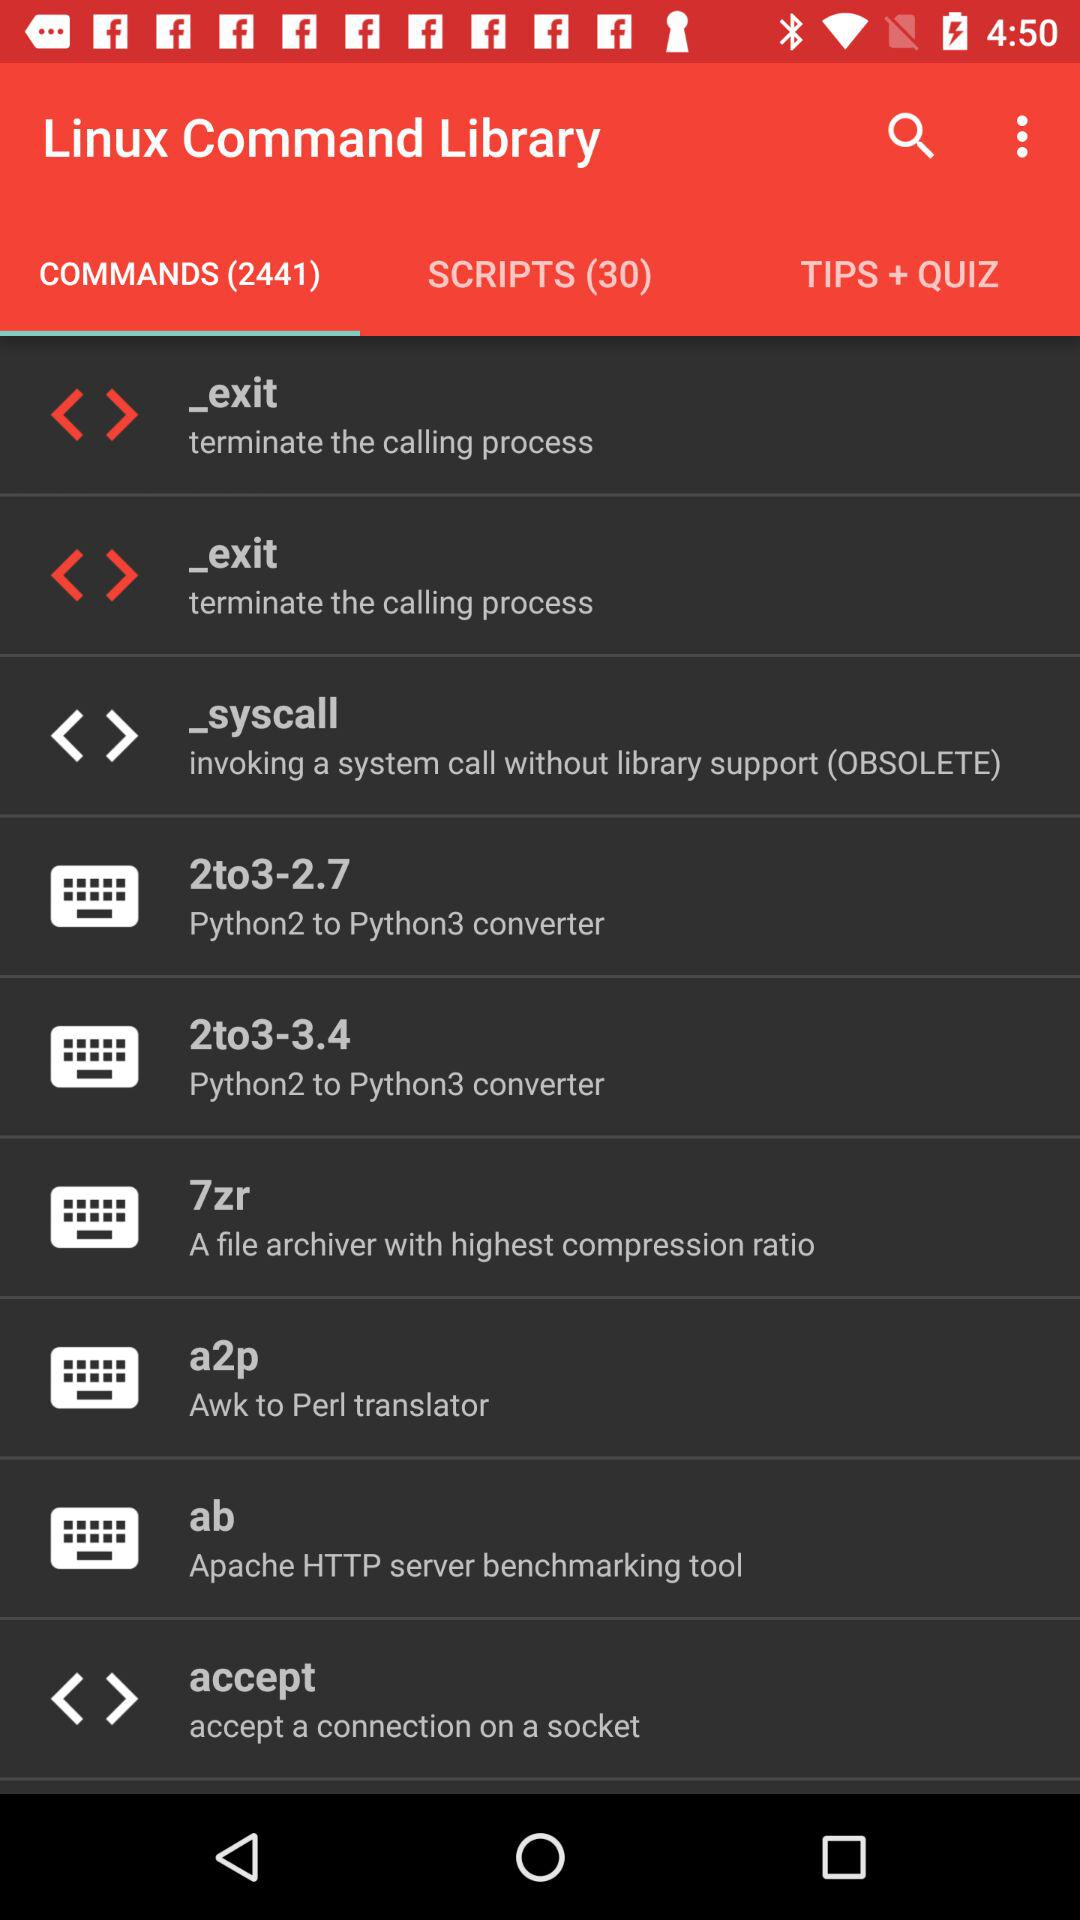Which tab is selected? The selected tab is "COMMANDS (2441)". 